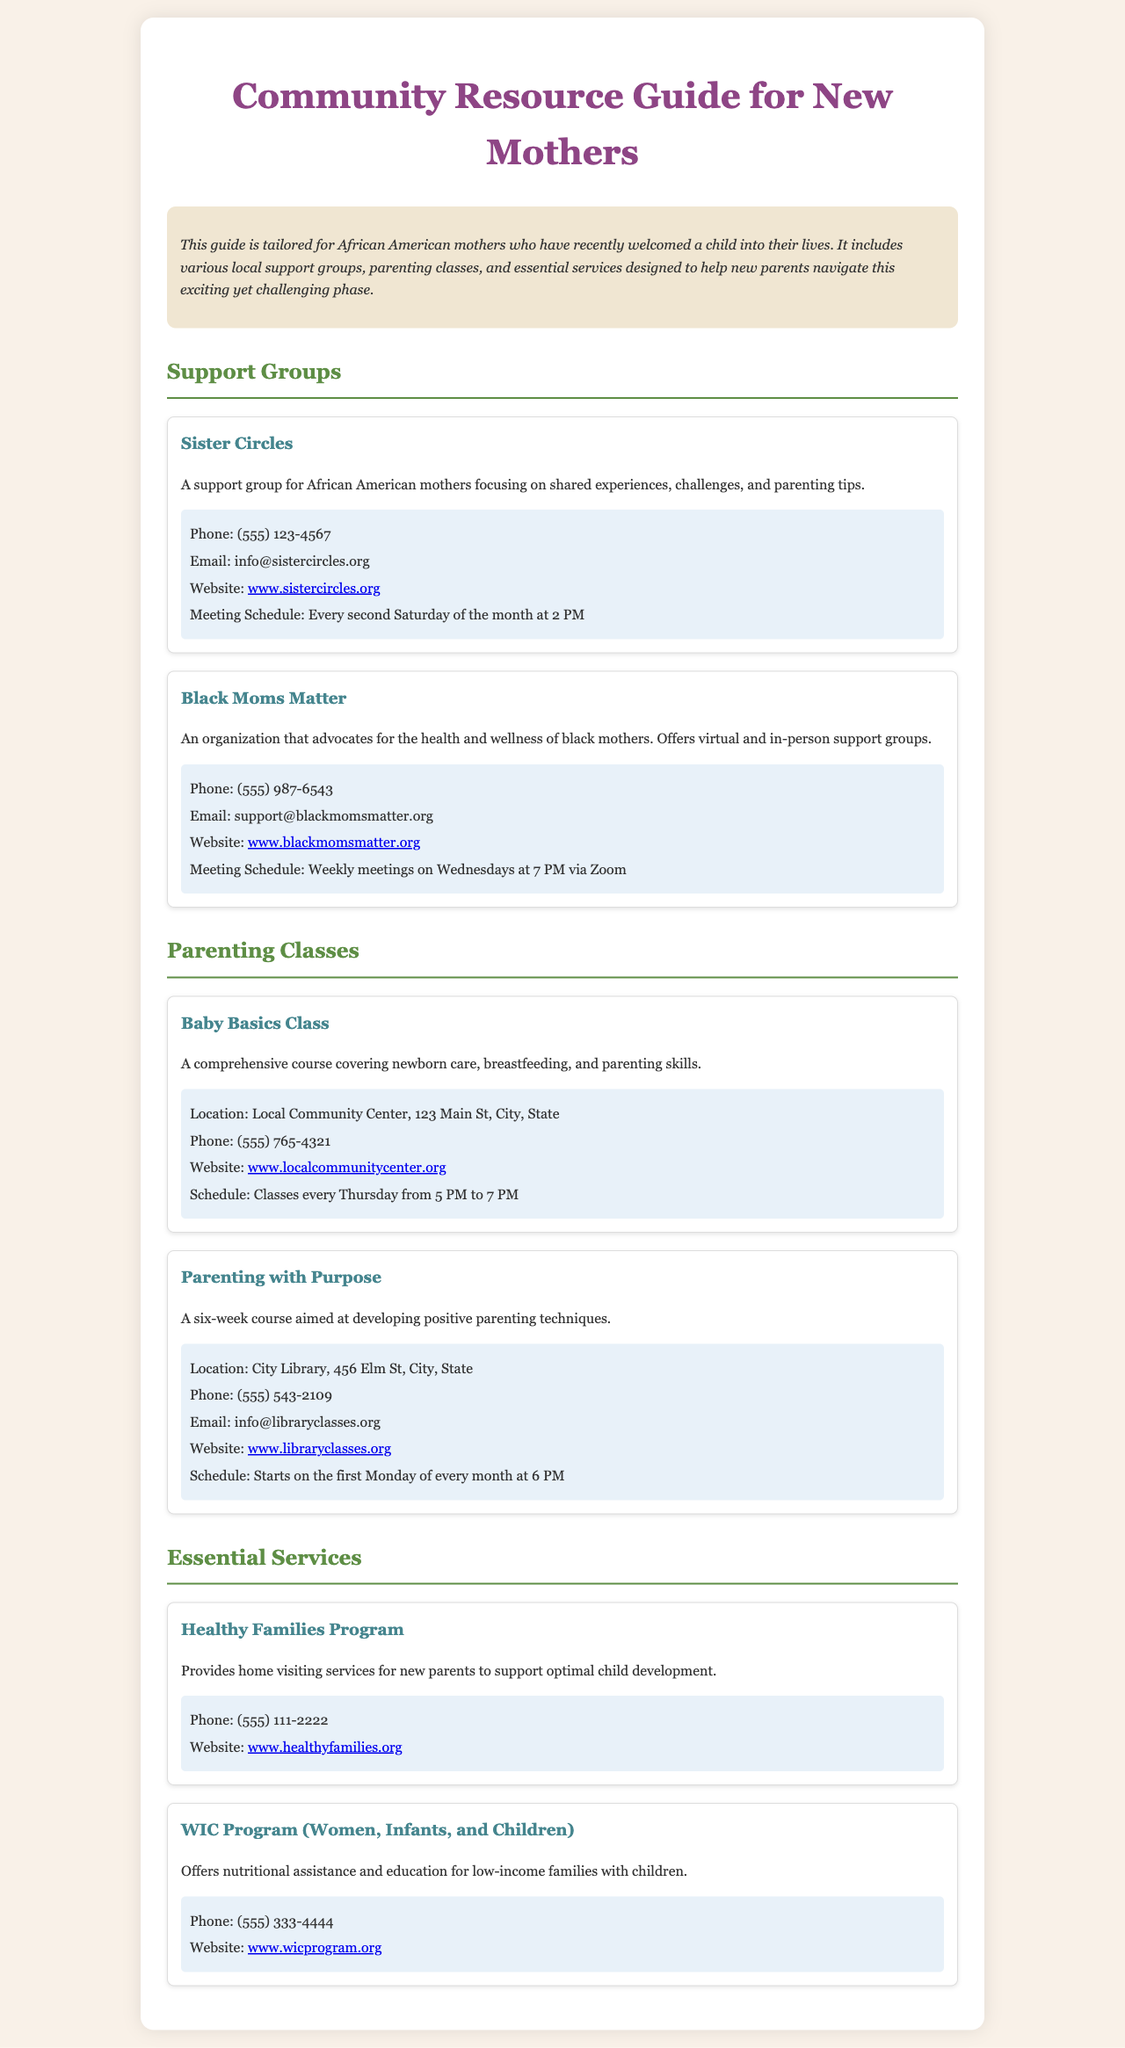What is the main purpose of the guide? The guide is designed to help African American mothers navigate the challenges of parenthood by providing local resources.
Answer: Tailored for African American mothers What is the phone number for Sister Circles? The phone number is listed in the contact section of the Sister Circles resource.
Answer: (555) 123-4567 When does the Black Moms Matter group meet? The meeting schedule for the Black Moms Matter group is noted in the document.
Answer: Weekly meetings on Wednesdays at 7 PM What location is the Baby Basics Class held at? The location for the Baby Basics Class is provided in the resource.
Answer: Local Community Center, 123 Main St, City, State What type of services does the Healthy Families Program provide? The document lists the services offered by the Healthy Families Program.
Answer: Home visiting services How often does the Parenting with Purpose course start? The schedule indicates how often the Parenting with Purpose course begins.
Answer: Every month What type of assistance does the WIC Program offer? The description of the WIC Program explains the nature of the assistance provided.
Answer: Nutritional assistance What is the website for Black Moms Matter? The website is included in the contact section for Black Moms Matter.
Answer: www.blackmomsmatter.org What colors are used for the headings in the document? The document describes the design elements used, including the colors of the headings.
Answer: #8e4585 and #5e8e45 